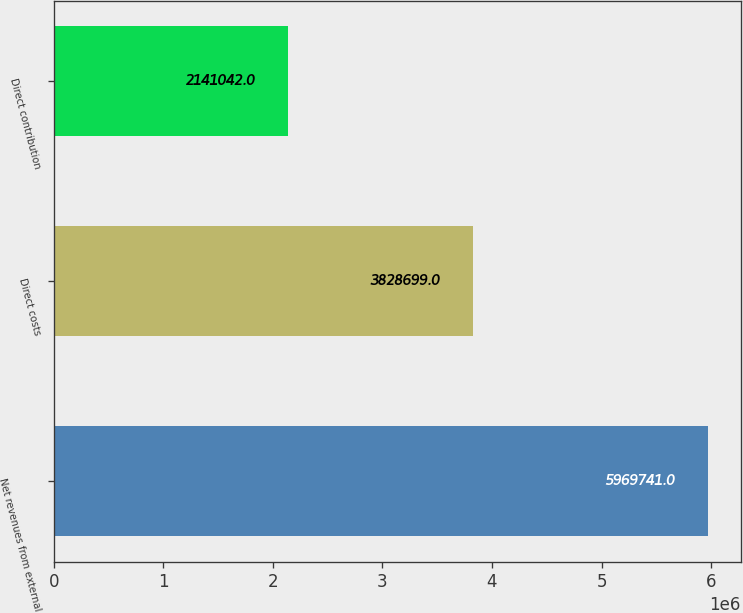Convert chart. <chart><loc_0><loc_0><loc_500><loc_500><bar_chart><fcel>Net revenues from external<fcel>Direct costs<fcel>Direct contribution<nl><fcel>5.96974e+06<fcel>3.8287e+06<fcel>2.14104e+06<nl></chart> 